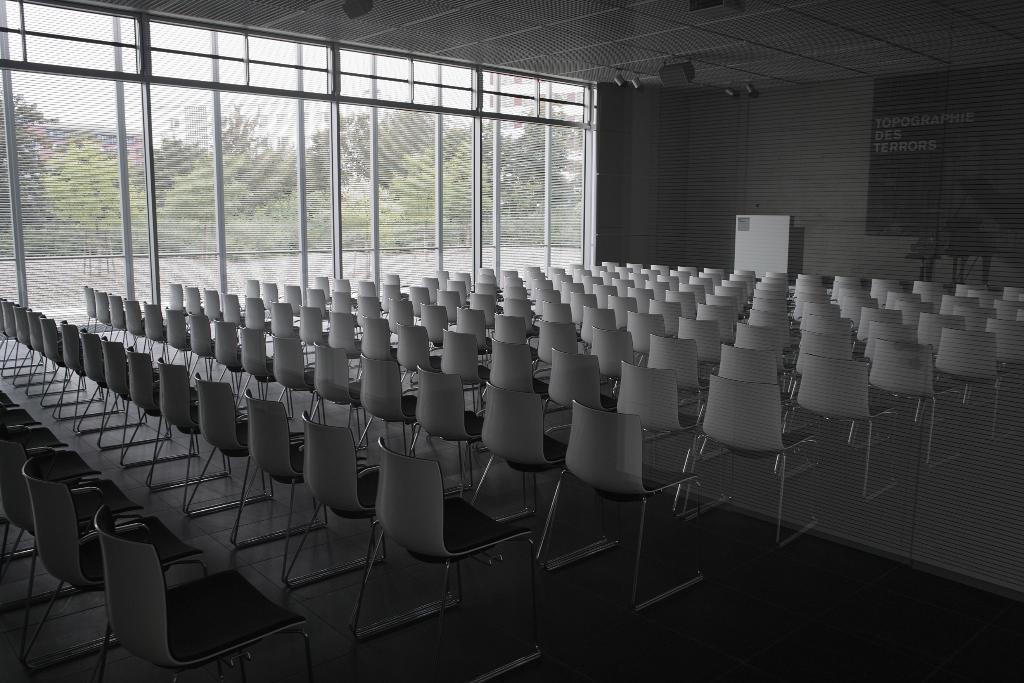Could you give a brief overview of what you see in this image? These are the chairs which are in white color. In the left side it's a glass wall. Outside this there are green trees. 